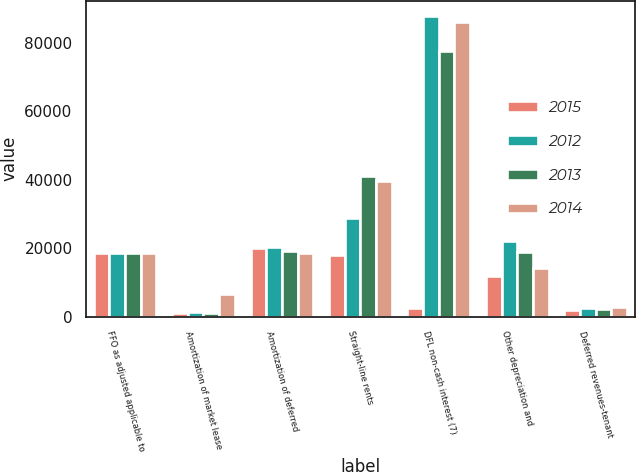Convert chart to OTSL. <chart><loc_0><loc_0><loc_500><loc_500><stacked_bar_chart><ecel><fcel>FFO as adjusted applicable to<fcel>Amortization of market lease<fcel>Amortization of deferred<fcel>Straight-line rents<fcel>DFL non-cash interest (7)<fcel>Other depreciation and<fcel>Deferred revenues-tenant<nl><fcel>2015<fcel>18702.5<fcel>1197<fcel>20014<fcel>18003<fcel>2600<fcel>11919<fcel>1883<nl><fcel>2012<fcel>18702.5<fcel>1295<fcel>20222<fcel>28859<fcel>87861<fcel>22223<fcel>2594<nl><fcel>2013<fcel>18702.5<fcel>949<fcel>19260<fcel>41032<fcel>77568<fcel>18864<fcel>2306<nl><fcel>2014<fcel>18702.5<fcel>6646<fcel>18541<fcel>39587<fcel>86055<fcel>14326<fcel>2906<nl></chart> 